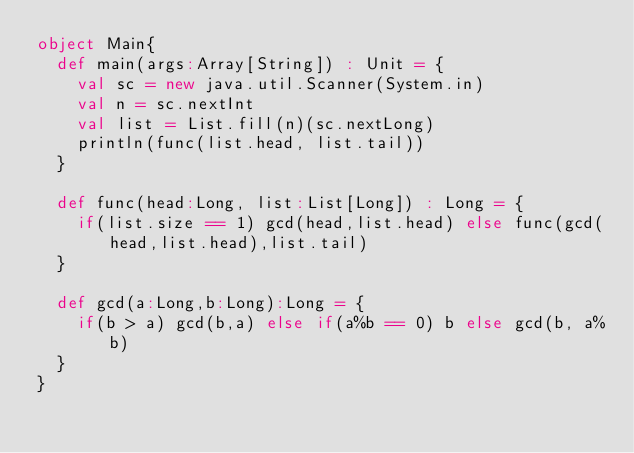Convert code to text. <code><loc_0><loc_0><loc_500><loc_500><_Scala_>object Main{
  def main(args:Array[String]) : Unit = {
    val sc = new java.util.Scanner(System.in)
    val n = sc.nextInt
    val list = List.fill(n)(sc.nextLong)
    println(func(list.head, list.tail))
  }

  def func(head:Long, list:List[Long]) : Long = {
    if(list.size == 1) gcd(head,list.head) else func(gcd(head,list.head),list.tail)
  }

  def gcd(a:Long,b:Long):Long = {
    if(b > a) gcd(b,a) else if(a%b == 0) b else gcd(b, a%b)
  }
}</code> 